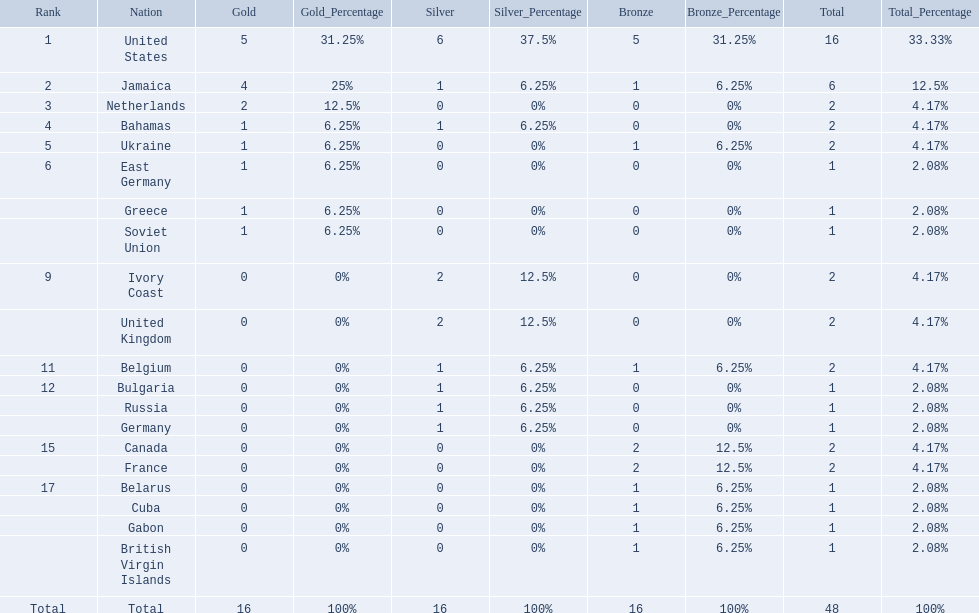What countries competed? United States, Jamaica, Netherlands, Bahamas, Ukraine, East Germany, Greece, Soviet Union, Ivory Coast, United Kingdom, Belgium, Bulgaria, Russia, Germany, Canada, France, Belarus, Cuba, Gabon, British Virgin Islands. Which countries won gold medals? United States, Jamaica, Netherlands, Bahamas, Ukraine, East Germany, Greece, Soviet Union. Which country had the second most medals? Jamaica. 